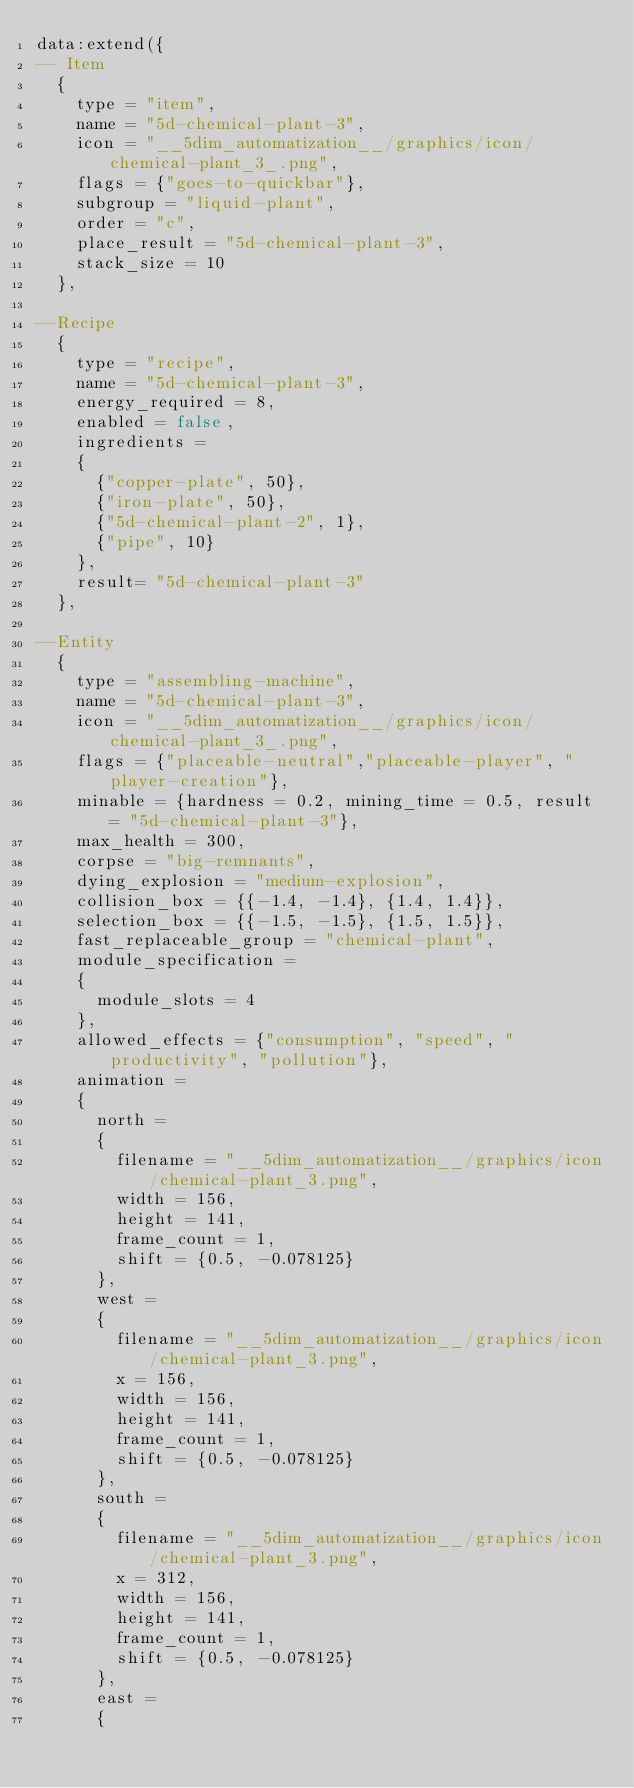Convert code to text. <code><loc_0><loc_0><loc_500><loc_500><_Lua_>data:extend({
-- Item
  {
    type = "item",
    name = "5d-chemical-plant-3",
    icon = "__5dim_automatization__/graphics/icon/chemical-plant_3_.png",
    flags = {"goes-to-quickbar"},
    subgroup = "liquid-plant",
    order = "c",
    place_result = "5d-chemical-plant-3",
    stack_size = 10
  },

--Recipe
  {
    type = "recipe",
    name = "5d-chemical-plant-3",
    energy_required = 8,
    enabled = false,
    ingredients =
    {
      {"copper-plate", 50},
      {"iron-plate", 50},
      {"5d-chemical-plant-2", 1},
      {"pipe", 10}
    },
    result= "5d-chemical-plant-3"
  },

--Entity
  {
    type = "assembling-machine",
    name = "5d-chemical-plant-3",
    icon = "__5dim_automatization__/graphics/icon/chemical-plant_3_.png",
    flags = {"placeable-neutral","placeable-player", "player-creation"},
    minable = {hardness = 0.2, mining_time = 0.5, result = "5d-chemical-plant-3"},
    max_health = 300,
    corpse = "big-remnants",
    dying_explosion = "medium-explosion",
    collision_box = {{-1.4, -1.4}, {1.4, 1.4}},
    selection_box = {{-1.5, -1.5}, {1.5, 1.5}},
	fast_replaceable_group = "chemical-plant",
    module_specification =
    {
      module_slots = 4
    },
    allowed_effects = {"consumption", "speed", "productivity", "pollution"},
    animation =
    {
      north =
      {
        filename = "__5dim_automatization__/graphics/icon/chemical-plant_3.png",
        width = 156,
        height = 141,
        frame_count = 1,
        shift = {0.5, -0.078125}
      },
      west =
      {
        filename = "__5dim_automatization__/graphics/icon/chemical-plant_3.png",
        x = 156,
        width = 156,
        height = 141,
        frame_count = 1,
        shift = {0.5, -0.078125}
      },
      south =
      {
        filename = "__5dim_automatization__/graphics/icon/chemical-plant_3.png",
        x = 312,
        width = 156,
        height = 141,
        frame_count = 1,
        shift = {0.5, -0.078125}
      },
      east =
      {</code> 